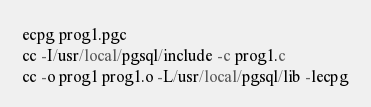<code> <loc_0><loc_0><loc_500><loc_500><_SQL_>ecpg prog1.pgc
cc -I/usr/local/pgsql/include -c prog1.c
cc -o prog1 prog1.o -L/usr/local/pgsql/lib -lecpg
</code> 